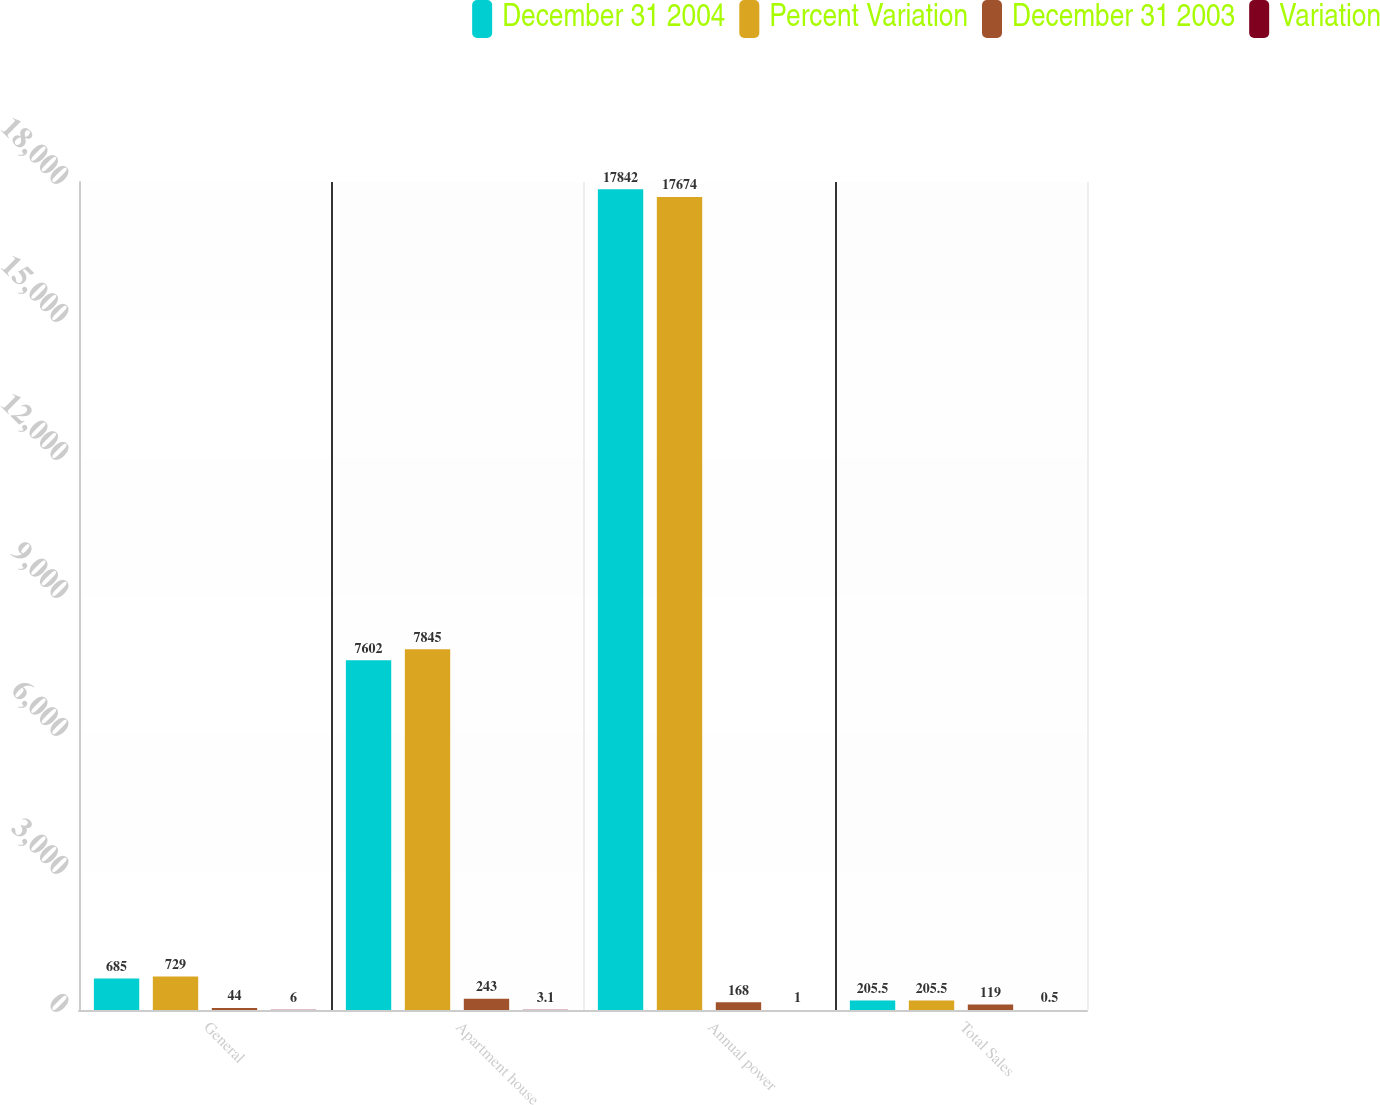Convert chart. <chart><loc_0><loc_0><loc_500><loc_500><stacked_bar_chart><ecel><fcel>General<fcel>Apartment house<fcel>Annual power<fcel>Total Sales<nl><fcel>December 31 2004<fcel>685<fcel>7602<fcel>17842<fcel>205.5<nl><fcel>Percent Variation<fcel>729<fcel>7845<fcel>17674<fcel>205.5<nl><fcel>December 31 2003<fcel>44<fcel>243<fcel>168<fcel>119<nl><fcel>Variation<fcel>6<fcel>3.1<fcel>1<fcel>0.5<nl></chart> 